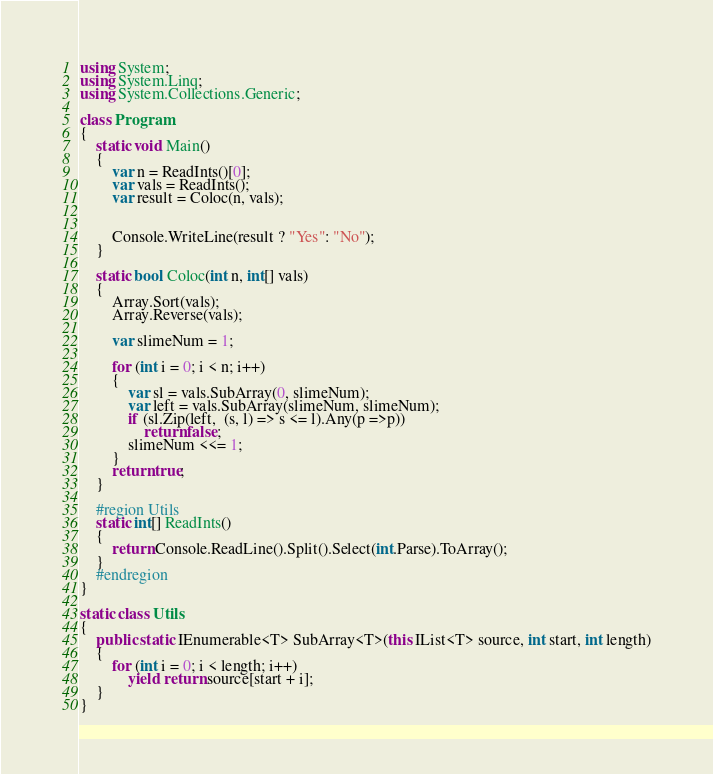<code> <loc_0><loc_0><loc_500><loc_500><_C#_>using System;
using System.Linq;
using System.Collections.Generic;

class Program
{
    static void Main()
    {
        var n = ReadInts()[0];
        var vals = ReadInts();
        var result = Coloc(n, vals);


        Console.WriteLine(result ? "Yes": "No");
    }

    static bool Coloc(int n, int[] vals)
    {
        Array.Sort(vals);
        Array.Reverse(vals);

        var slimeNum = 1;

        for (int i = 0; i < n; i++)
        {
            var sl = vals.SubArray(0, slimeNum);
            var left = vals.SubArray(slimeNum, slimeNum);
            if (sl.Zip(left,  (s, l) => s <= l).Any(p =>p))
                return false;
            slimeNum <<= 1;
        }
        return true;
    }

    #region Utils
    static int[] ReadInts()
    {
        return Console.ReadLine().Split().Select(int.Parse).ToArray();
    }
    #endregion
}

static class Utils
{
    public static IEnumerable<T> SubArray<T>(this IList<T> source, int start, int length)
    {
        for (int i = 0; i < length; i++)
            yield return source[start + i];
    }
}
</code> 